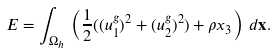<formula> <loc_0><loc_0><loc_500><loc_500>E = \int _ { \Omega _ { h } } \, \left ( \frac { 1 } { 2 } ( ( u _ { 1 } ^ { g } ) ^ { 2 } + ( u _ { 2 } ^ { g } ) ^ { 2 } ) + \rho x _ { 3 } \right ) \, d \mathbf x .</formula> 